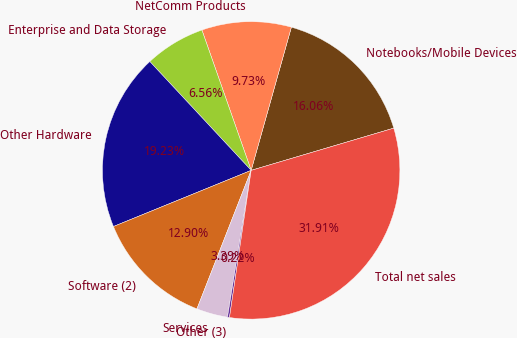Convert chart to OTSL. <chart><loc_0><loc_0><loc_500><loc_500><pie_chart><fcel>Notebooks/Mobile Devices<fcel>NetComm Products<fcel>Enterprise and Data Storage<fcel>Other Hardware<fcel>Software (2)<fcel>Services<fcel>Other (3)<fcel>Total net sales<nl><fcel>16.06%<fcel>9.73%<fcel>6.56%<fcel>19.23%<fcel>12.9%<fcel>3.39%<fcel>0.22%<fcel>31.91%<nl></chart> 